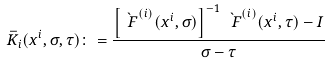Convert formula to latex. <formula><loc_0><loc_0><loc_500><loc_500>\bar { K } _ { i } ( x ^ { i } , \sigma , \tau ) \colon = \frac { \left [ \grave { \ F } ^ { ( i ) } ( x ^ { i } , \sigma ) \right ] ^ { - 1 } \grave { \ F } ^ { ( i ) } ( x ^ { i } , \tau ) - I } { \sigma - \tau }</formula> 